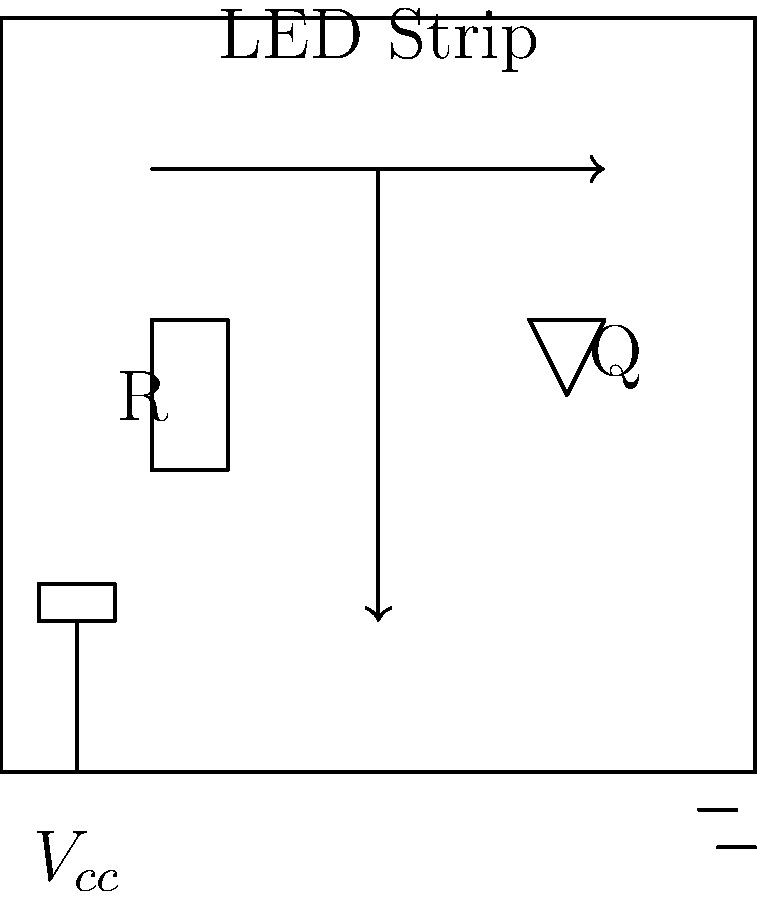You're designing a smart lighting system for a new vegan cafe, featuring LED strips that change color based on the time of day to create different ambiances. If the LED strip requires a forward voltage of 12V and draws 1.5A of current, what should be the minimum power rating of the transistor (Q) used to control the LED strip? To determine the minimum power rating of the transistor, we need to calculate the power dissipated by the LED strip, which will be handled by the transistor. We can do this using the following steps:

1. Calculate the power consumed by the LED strip:
   $P = V \times I$
   Where:
   $P$ is power in watts (W)
   $V$ is voltage in volts (V)
   $I$ is current in amperes (A)

2. Substitute the given values:
   $P = 12V \times 1.5A = 18W$

3. The transistor must be able to handle at least this amount of power. However, it's good practice to add a safety margin to account for variations in voltage and current, as well as to ensure the transistor operates within its safe operating area.

4. A common rule of thumb is to choose a transistor with a power rating at least 50% higher than the calculated power:
   $P_{transistor} = 18W \times 1.5 = 27W$

5. Therefore, we should choose a transistor with a minimum power rating of 27W or higher.

Note: In practice, you would also need to consider other factors such as the maximum collector-emitter voltage, maximum collector current, and the transistor's thermal characteristics. However, for the purposes of this question, we're focusing solely on the power rating.
Answer: 27W 